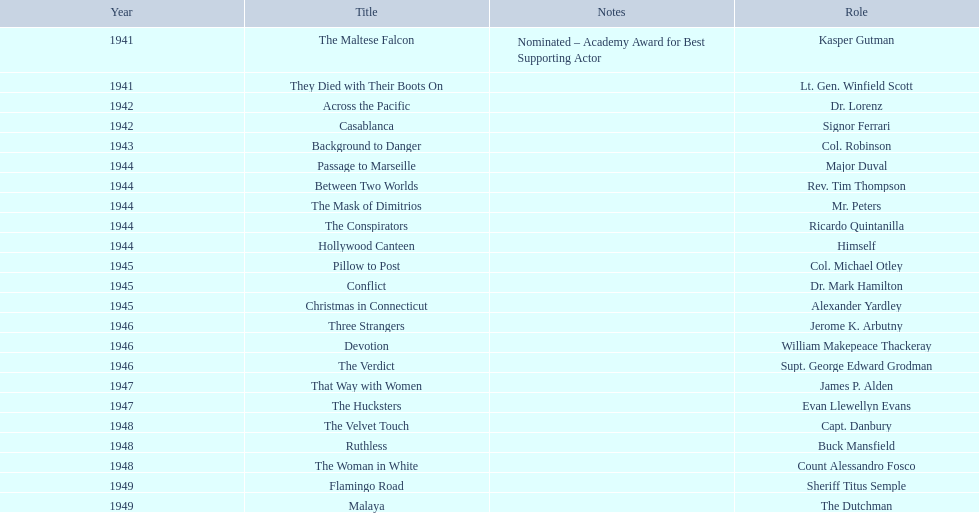What are all of the movies sydney greenstreet acted in? The Maltese Falcon, They Died with Their Boots On, Across the Pacific, Casablanca, Background to Danger, Passage to Marseille, Between Two Worlds, The Mask of Dimitrios, The Conspirators, Hollywood Canteen, Pillow to Post, Conflict, Christmas in Connecticut, Three Strangers, Devotion, The Verdict, That Way with Women, The Hucksters, The Velvet Touch, Ruthless, The Woman in White, Flamingo Road, Malaya. What are all of the title notes? Nominated – Academy Award for Best Supporting Actor. Which film was the award for? The Maltese Falcon. 